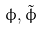<formula> <loc_0><loc_0><loc_500><loc_500>\phi , \tilde { \phi }</formula> 